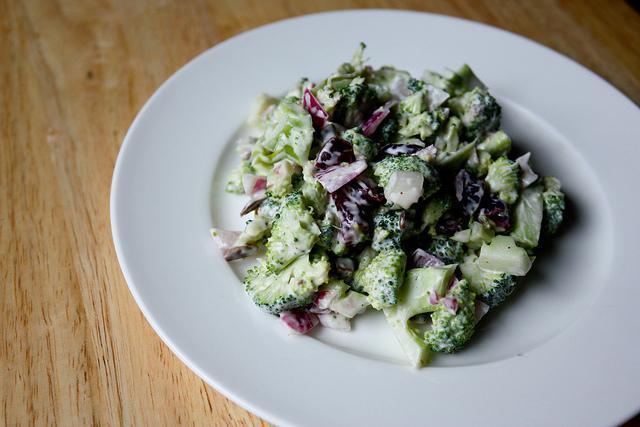How many broccolis are in the photo?
Give a very brief answer. 7. 